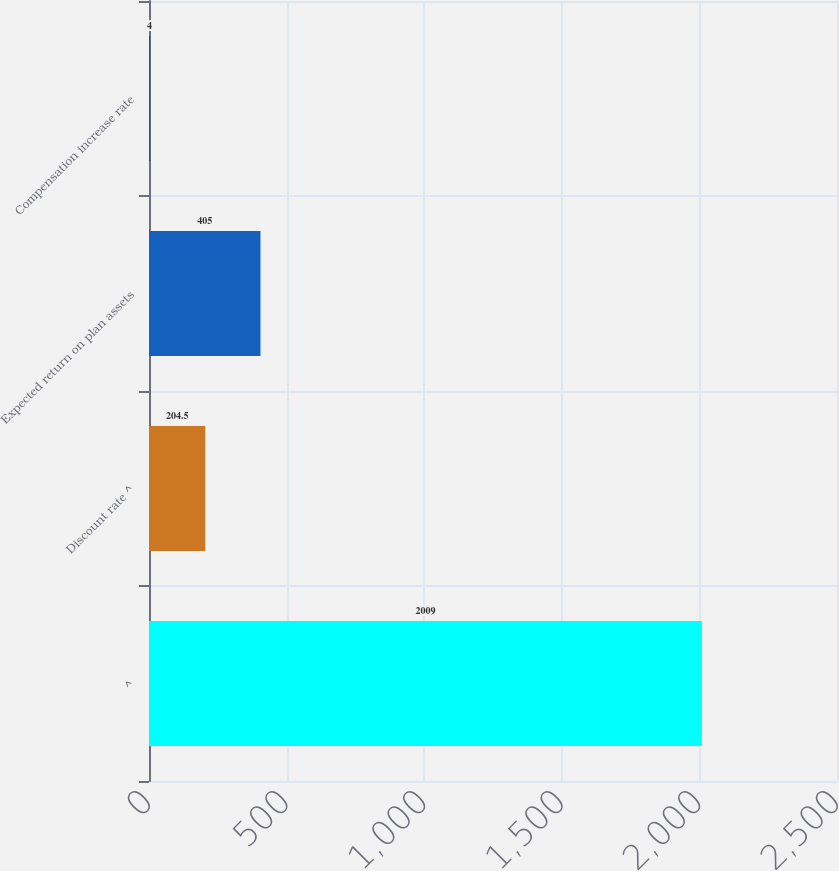Convert chart. <chart><loc_0><loc_0><loc_500><loc_500><bar_chart><fcel>^<fcel>Discount rate ^<fcel>Expected return on plan assets<fcel>Compensation increase rate<nl><fcel>2009<fcel>204.5<fcel>405<fcel>4<nl></chart> 